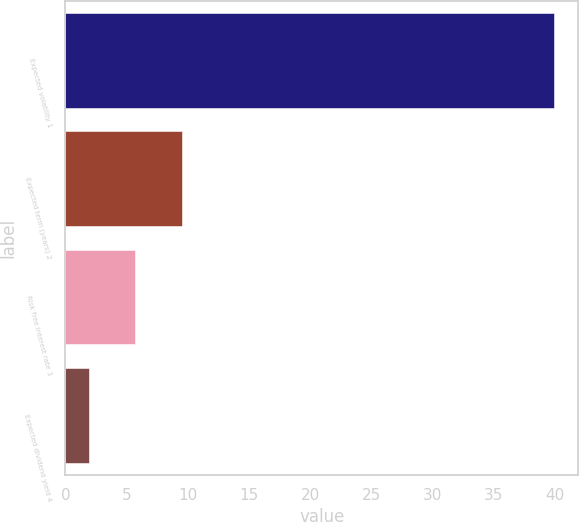<chart> <loc_0><loc_0><loc_500><loc_500><bar_chart><fcel>Expected volatility 1<fcel>Expected term (years) 2<fcel>Risk free interest rate 3<fcel>Expected dividend yield 4<nl><fcel>39.9<fcel>9.5<fcel>5.7<fcel>1.9<nl></chart> 